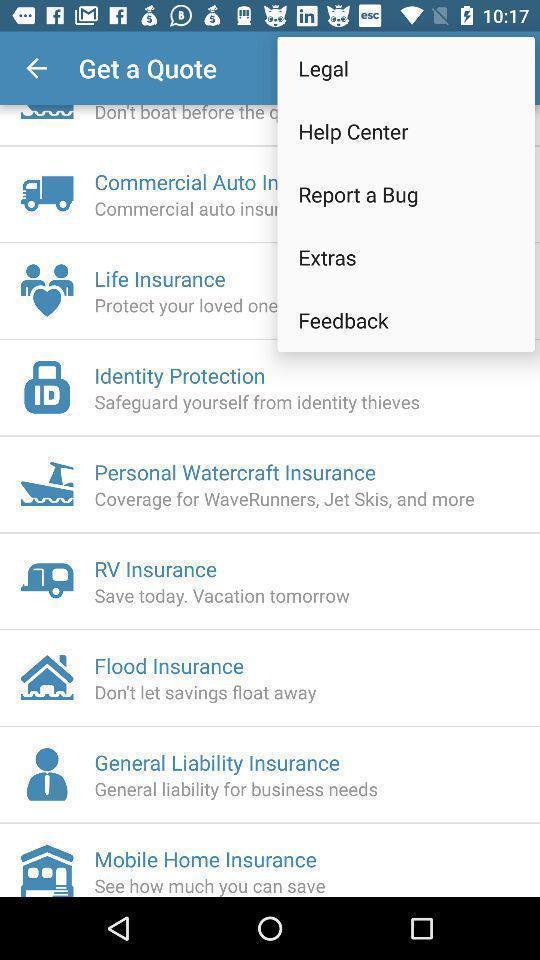Summarize the information in this screenshot. Screen shows about legal information. 